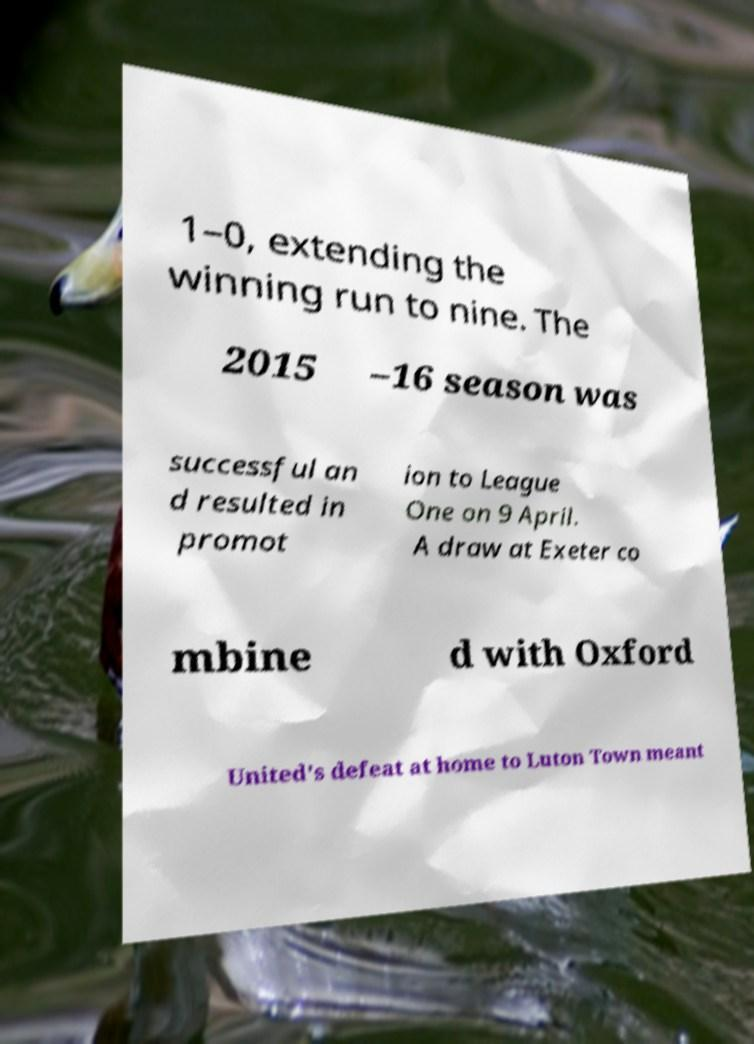Can you read and provide the text displayed in the image?This photo seems to have some interesting text. Can you extract and type it out for me? 1–0, extending the winning run to nine. The 2015 –16 season was successful an d resulted in promot ion to League One on 9 April. A draw at Exeter co mbine d with Oxford United's defeat at home to Luton Town meant 